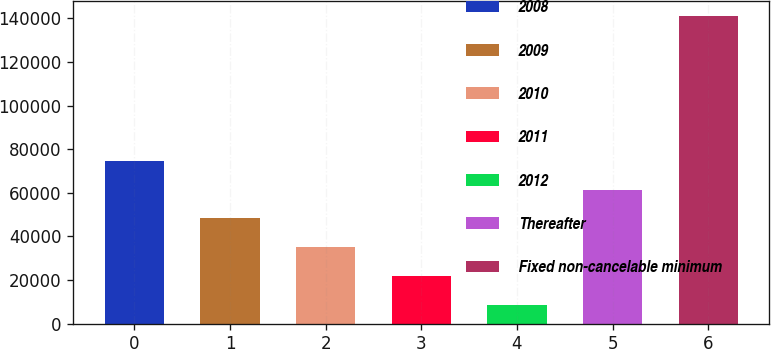Convert chart. <chart><loc_0><loc_0><loc_500><loc_500><bar_chart><fcel>2008<fcel>2009<fcel>2010<fcel>2011<fcel>2012<fcel>Thereafter<fcel>Fixed non-cancelable minimum<nl><fcel>74745.5<fcel>48267.3<fcel>35028.2<fcel>21789.1<fcel>8550<fcel>61506.4<fcel>140941<nl></chart> 